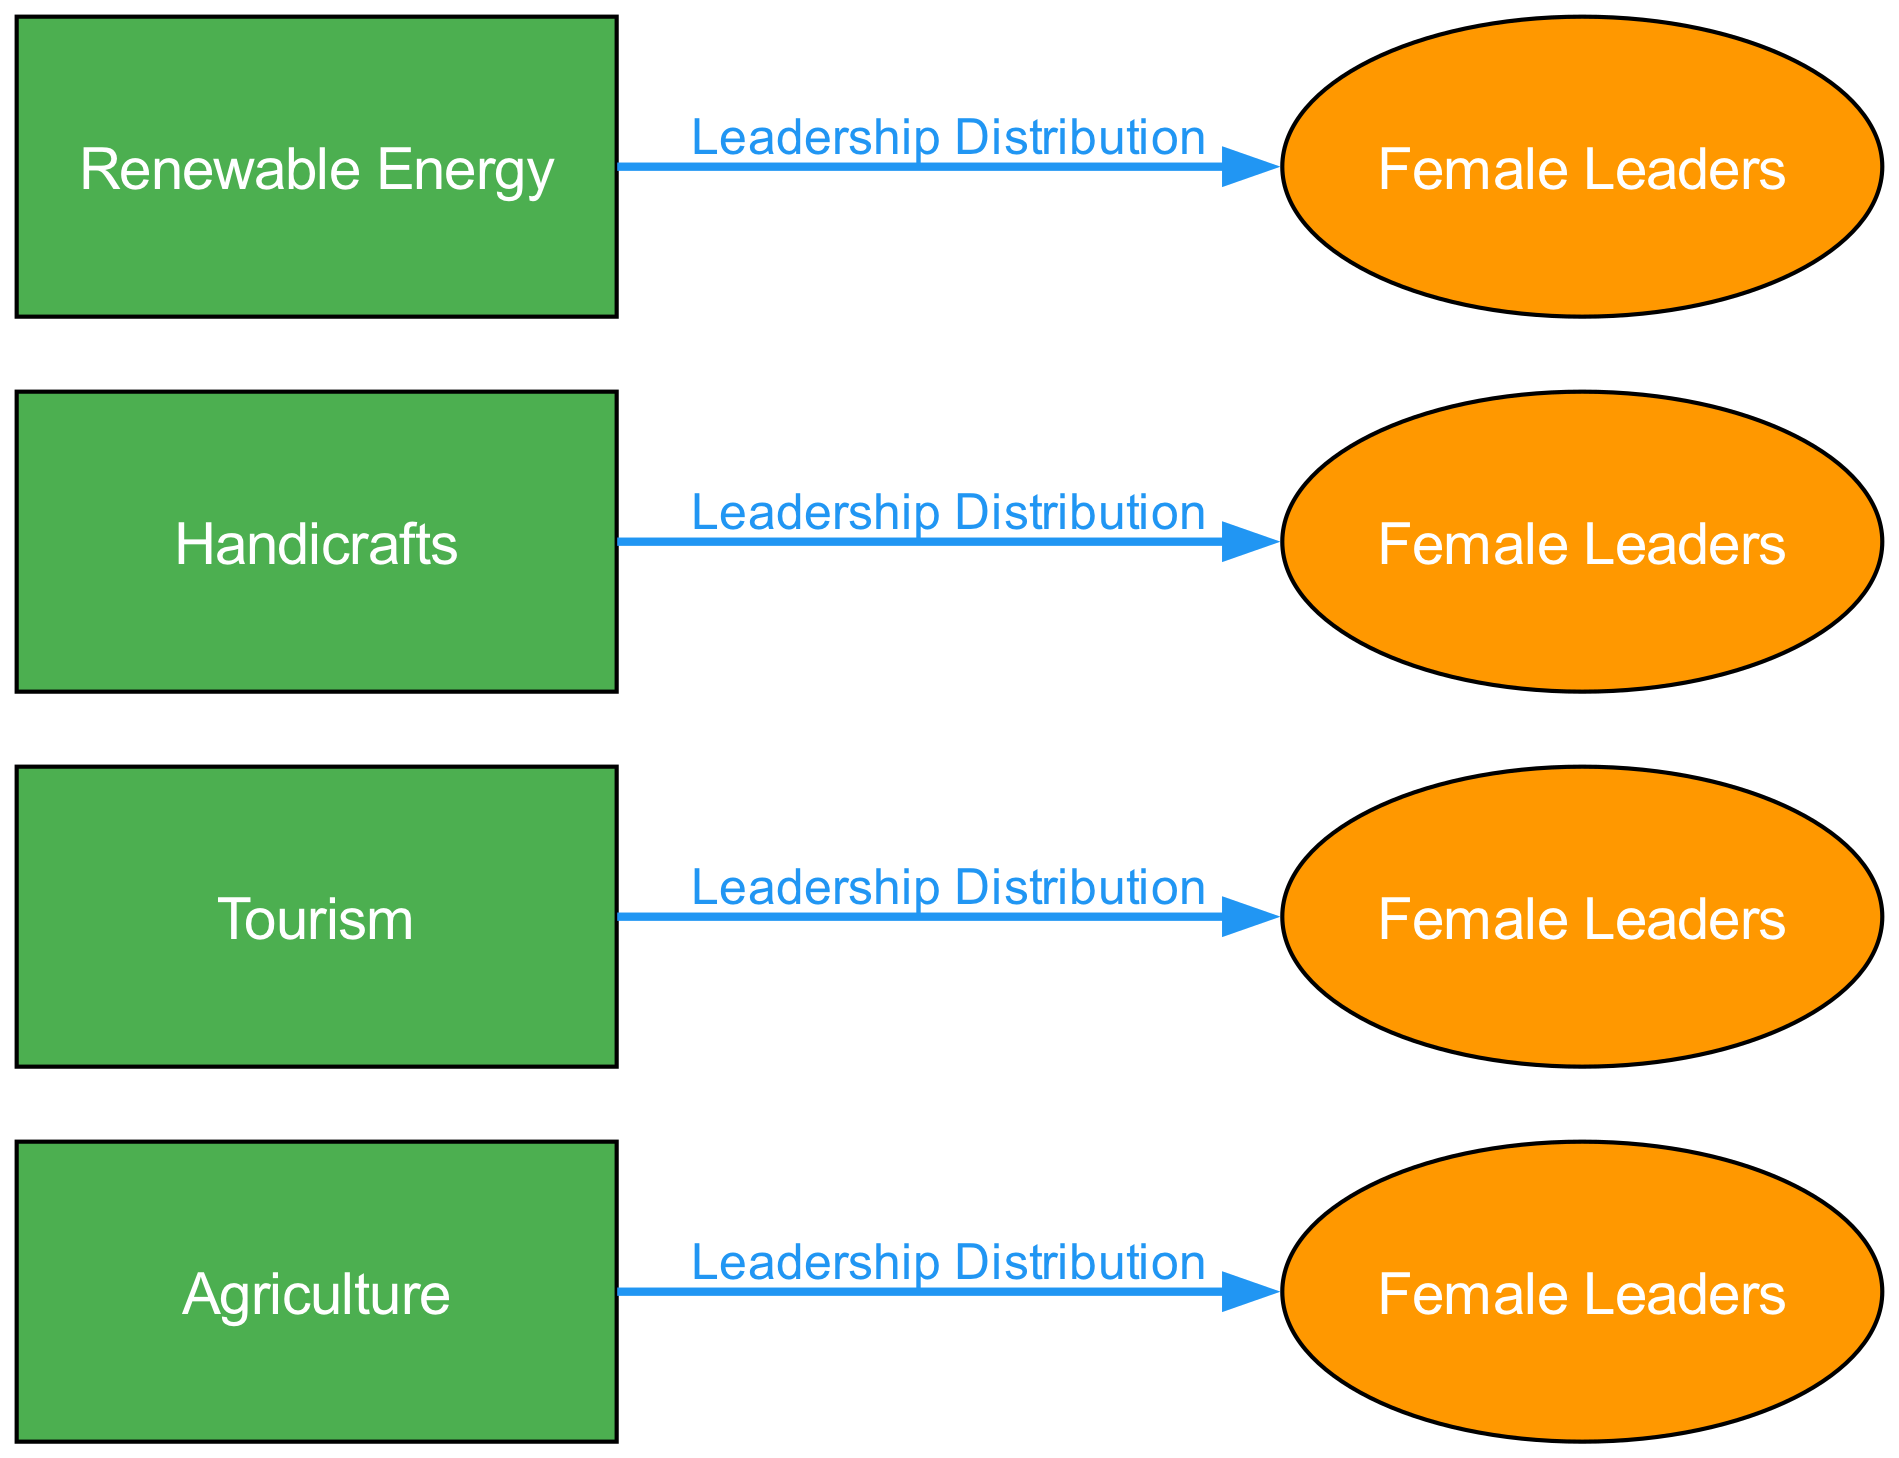What's the total number of sectors represented in the diagram? The diagram lists four distinct sectors: Agriculture, Tourism, Handicrafts, and Renewable Energy. Counting these gives us the total number of sectors.
Answer: 4 Which sector has the female leaders connected to it by the orange ellipse? The orange ellipse represents female leaders, and tracing back the ellipse for agriculture, tourism, handicrafts, and renewable energy, we can see that all are connected to their respective sectors, but we need to identify a specific sector connected to a particular female leaders group. Based on the diagram, it can be noted that each sector connects to its female leaders with a labeled edge.
Answer: Agriculture, Tourism, Handicrafts, Renewable Energy What color is used for the sector nodes in the diagram? The sector nodes (Agriculture, Tourism, Handicrafts, Renewable Energy) are all depicted in green, as indicated by the chosen color scheme for the rectangular nodes.
Answer: Green How many edges are present in the diagram? Each sector has one edge leading to its corresponding female leaders group, and there are four sectors depicted in the diagram. Therefore, the total number of edges is the same as the number of sectors.
Answer: 4 What is the purpose of the label "Leadership Distribution" on the edges? The label "Leadership Distribution" indicates the nature of the connection between each sector and its corresponding female leaders, specifically highlighting the proportion of women leaders in that particular sector. This descriptive label clarifies the relationship represented by the edge.
Answer: Proportion of women leaders Which sector is associated with renewable energy leadership? By examining the nodes and edges in the diagram, we identify that the sector labeled "Renewable Energy" has a direct edge connecting it to "Female Leaders" in renewable energy.
Answer: Renewable Energy What shape represents the female leaders in the diagram? The female leaders in the diagram are represented with ellipse shapes in contrast to the sector nodes, which are rectangular. This distinction is achieved through the different styles used for the nodes.
Answer: Ellipse 